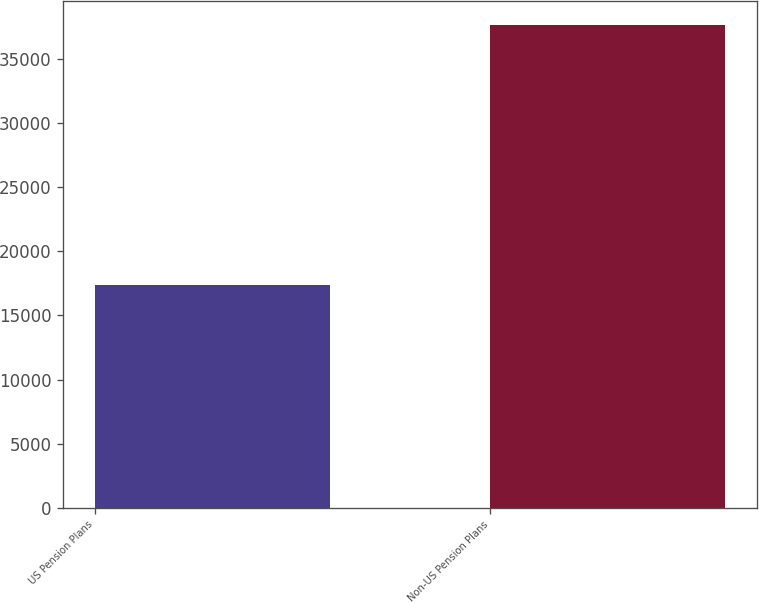<chart> <loc_0><loc_0><loc_500><loc_500><bar_chart><fcel>US Pension Plans<fcel>Non-US Pension Plans<nl><fcel>17359<fcel>37661<nl></chart> 